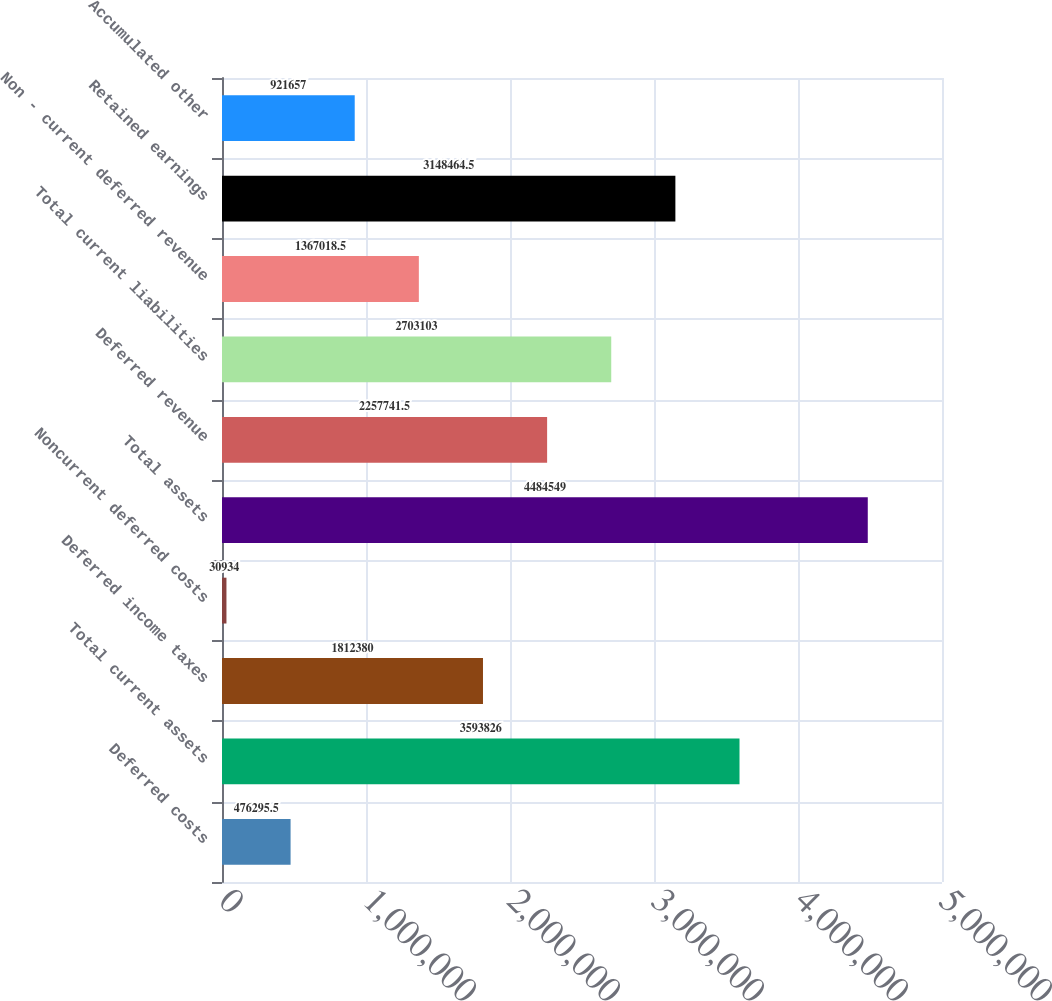Convert chart. <chart><loc_0><loc_0><loc_500><loc_500><bar_chart><fcel>Deferred costs<fcel>Total current assets<fcel>Deferred income taxes<fcel>Noncurrent deferred costs<fcel>Total assets<fcel>Deferred revenue<fcel>Total current liabilities<fcel>Non - current deferred revenue<fcel>Retained earnings<fcel>Accumulated other<nl><fcel>476296<fcel>3.59383e+06<fcel>1.81238e+06<fcel>30934<fcel>4.48455e+06<fcel>2.25774e+06<fcel>2.7031e+06<fcel>1.36702e+06<fcel>3.14846e+06<fcel>921657<nl></chart> 